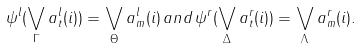<formula> <loc_0><loc_0><loc_500><loc_500>\psi ^ { l } ( \bigvee _ { \Gamma } a ^ { l } _ { t } ( i ) ) = \bigvee _ { \Theta } a ^ { l } _ { m } ( i ) \, a n d \, \psi ^ { r } ( \bigvee _ { \Delta } a ^ { r } _ { t } ( i ) ) = \bigvee _ { \Lambda } a ^ { r } _ { m } ( i ) .</formula> 